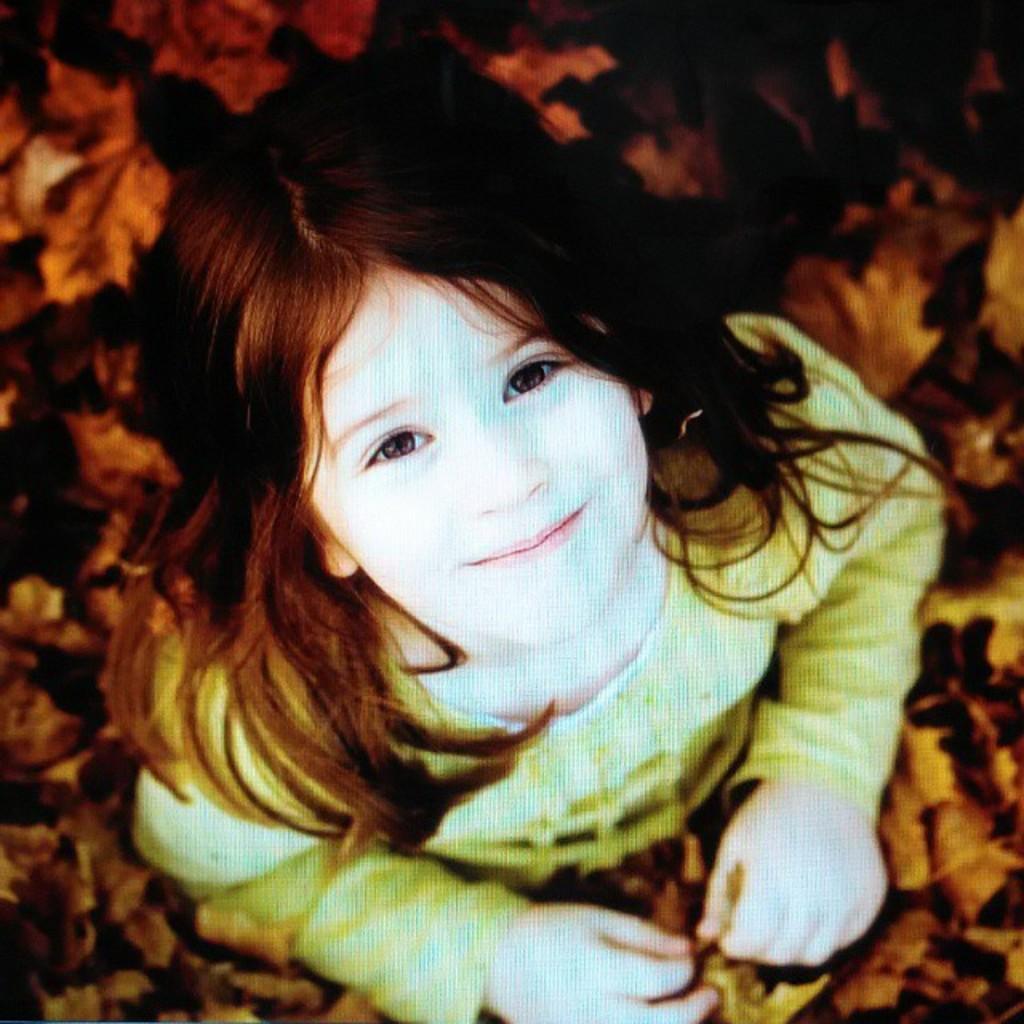Can you describe this image briefly? In this image, we can see a girl is watching and smiling. Here we can see leaves. It looks like a poster. 